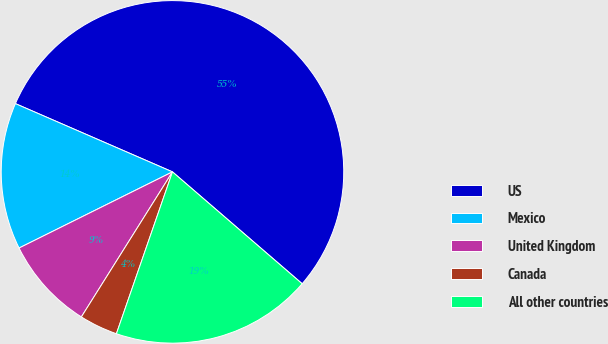<chart> <loc_0><loc_0><loc_500><loc_500><pie_chart><fcel>US<fcel>Mexico<fcel>United Kingdom<fcel>Canada<fcel>All other countries<nl><fcel>54.81%<fcel>13.86%<fcel>8.74%<fcel>3.62%<fcel>18.98%<nl></chart> 